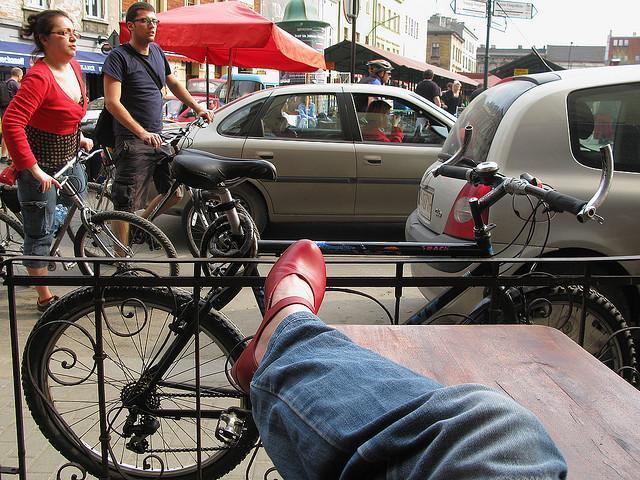How many people can be seen?
Give a very brief answer. 3. How many bicycles are there?
Give a very brief answer. 3. How many dining tables can be seen?
Give a very brief answer. 1. How many cars are there?
Give a very brief answer. 2. How many elephants are walking in the picture?
Give a very brief answer. 0. 